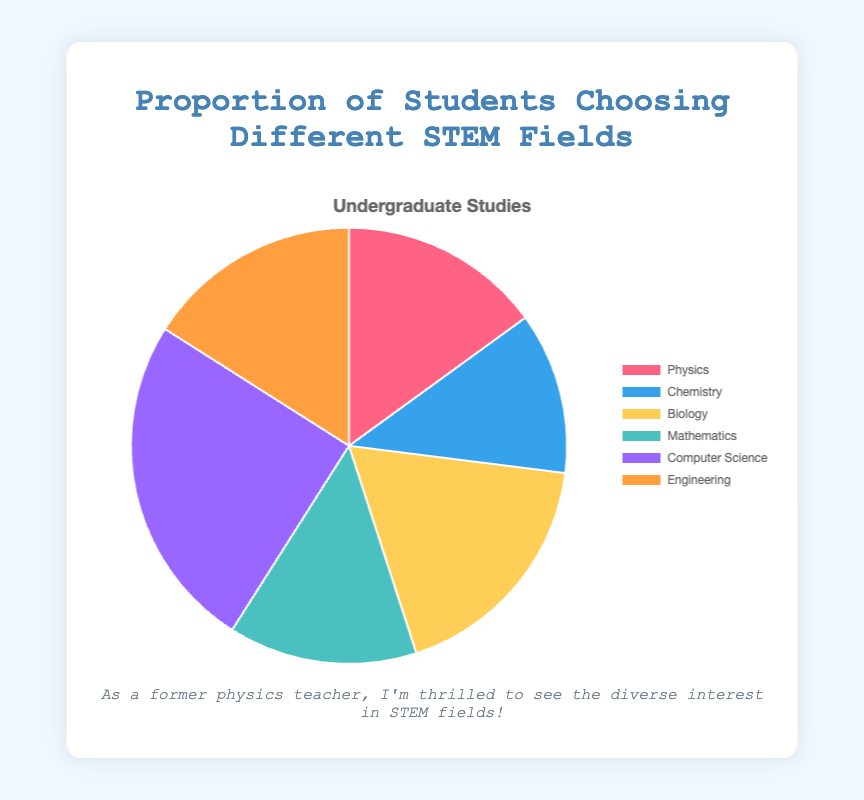Which field has the highest proportion of students? To find the field with the highest proportion, look at the data values in the chart. The field with the largest slice in the pie chart is Computer Science with 25%.
Answer: Computer Science Which two fields have the smallest combined proportion? We need to find the two fields with the smallest slices on the chart. Chemistry has 12% and Physics has 15%. Adding these gives 12% + 15% = 27%.
Answer: Chemistry and Physics What is the difference in proportion between the most and least chosen fields? The most chosen field is Computer Science with 25%, and the least chosen field is Chemistry with 12%. Subtracting these gives 25% - 12% = 13%.
Answer: 13% What is the total proportion of students choosing Biology and Engineering combined? To find the total proportion for Biology and Engineering, add their values. Biology is 18% and Engineering is 16%. Adding these gives 18% + 16% = 34%.
Answer: 34% How much more popular is Computer Science compared to Mathematics? Computer Science has 25% and Mathematics has 14%. Subtracting these gives 25% - 14% = 11%.
Answer: 11% What proportion of students chose either Physics or Mathematics? To find the combined proportion for Physics and Mathematics, add their values. Physics is 15% and Mathematics is 14%. Adding these gives 15% + 14% = 29%.
Answer: 29% If you were to combine Chemistry, Biology, and Engineering, what proportion of students would that represent? To find the combined proportion, add the values of Chemistry, Biology, and Engineering. Chemistry is 12%, Biology is 18%, and Engineering is 16%. Adding these gives 12% + 18% + 16% = 46%.
Answer: 46% What is the average proportion of students across all fields shown? To calculate the average, sum all the proportions and divide by the number of fields. The proportions are 15%, 12%, 18%, 14%, 25%, and 16%. Summing these gives 100%. Dividing by 6 fields gives 100% / 6 = ~16.67%.
Answer: ~16.67% What are the two most chosen fields and their combined proportion of students? Look for the two fields with the highest values. These are Computer Science with 25% and Biology with 18%. Adding these gives 25% + 18% = 43%.
Answer: Computer Science and Biology, 43% If another field was added that had 10% of the students, how would that affect the proportion of the current fields? Adding another field with 10% means the total is now 110%, causing each field's proportion to be adjusted accordingly. For example, the new proportion for Computer Science would be (25/110) * 100% = ~22.73%.
Answer: It's proportional, approximately 22.73% for Computer Science (example calculation) 